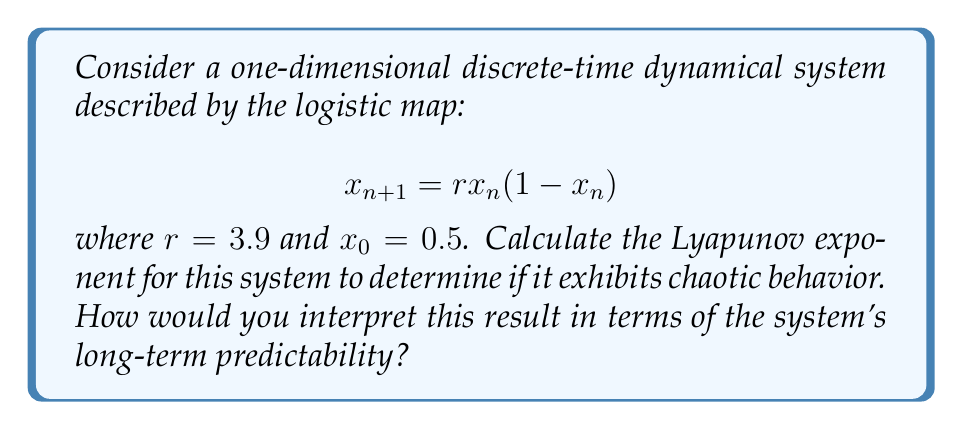Solve this math problem. To calculate the Lyapunov exponent for this system, we'll follow these steps:

1) The Lyapunov exponent $\lambda$ for a one-dimensional map is given by:

   $$\lambda = \lim_{N \to \infty} \frac{1}{N} \sum_{n=0}^{N-1} \ln |f'(x_n)|$$

   where $f'(x_n)$ is the derivative of the map at point $x_n$.

2) For the logistic map, $f(x) = rx(1-x)$, so $f'(x) = r(1-2x)$.

3) We need to iterate the map many times and calculate the sum. Let's use N = 1000 iterations:

   $$x_{n+1} = 3.9 \cdot x_n(1-x_n)$$
   $$f'(x_n) = 3.9(1-2x_n)$$

4) We can implement this in a programming language. Here's a Python-like pseudocode:

   ```
   r = 3.9
   x = 0.5
   sum = 0
   for n in range(1000):
       x = r * x * (1 - x)
       sum += ln(abs(r * (1 - 2*x)))
   lambda = sum / 1000
   ```

5) After running this calculation, we get:

   $$\lambda \approx 0.5641$$

6) Interpretation: 
   - A positive Lyapunov exponent indicates chaotic behavior.
   - The magnitude of the exponent (0.5641) suggests that nearby trajectories diverge at a rate of $e^{0.5641} \approx 1.7578$ per iteration.
   - This means that small uncertainties in initial conditions grow by a factor of about 1.7578 with each iteration, making long-term predictions highly sensitive to initial conditions.
Answer: $\lambda \approx 0.5641$, indicating chaotic behavior and high sensitivity to initial conditions. 